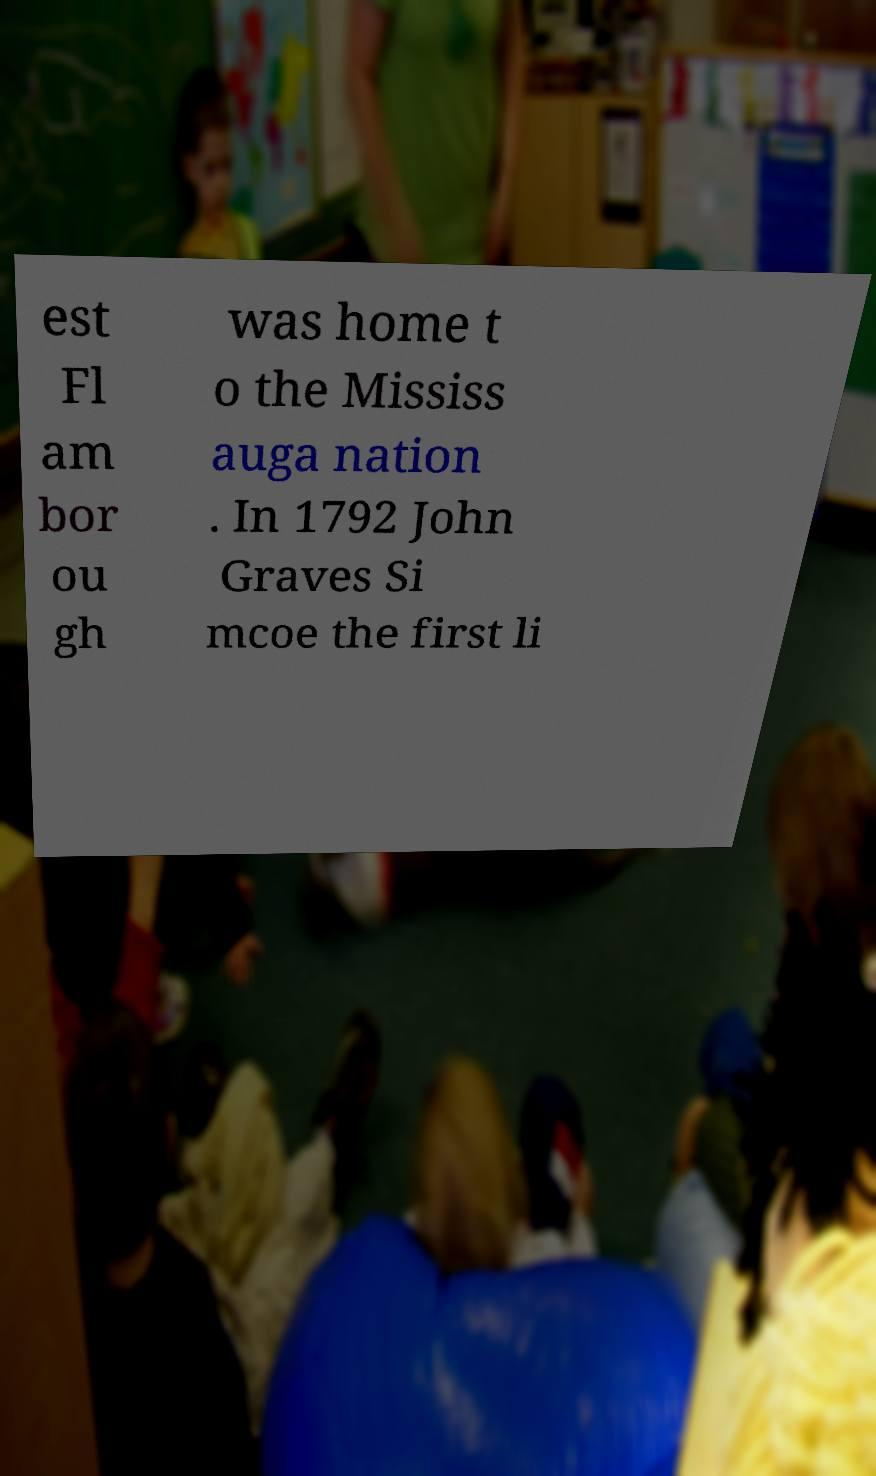Please identify and transcribe the text found in this image. est Fl am bor ou gh was home t o the Mississ auga nation . In 1792 John Graves Si mcoe the first li 